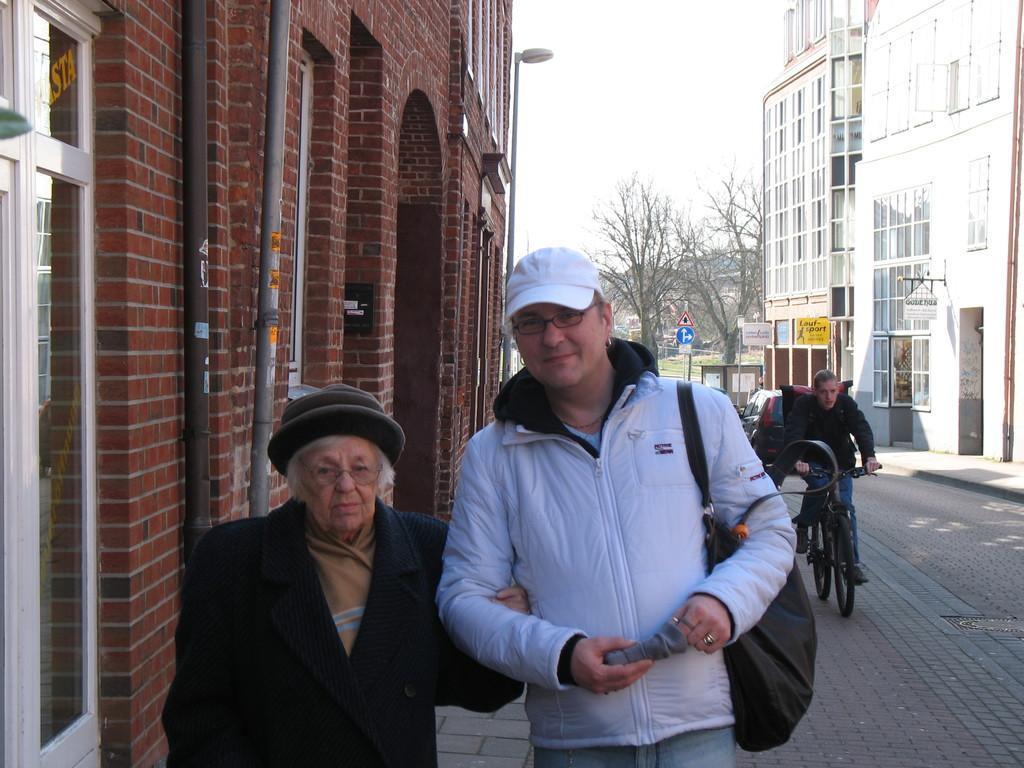Can you describe this image briefly? In this picture we can see two persons standing on the road. he is carrying his bag. He has spectacles and she wear a cap. Here we can see a person on the bicycle. These are the buildings. And there is a sky. Here we can see the trees. and this is the pole. 